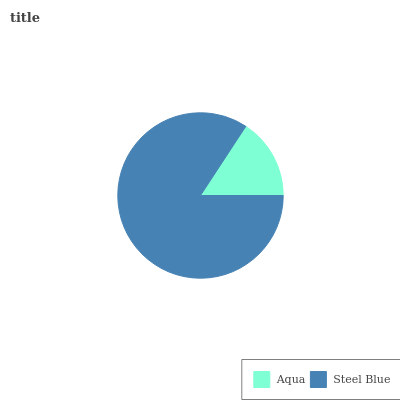Is Aqua the minimum?
Answer yes or no. Yes. Is Steel Blue the maximum?
Answer yes or no. Yes. Is Steel Blue the minimum?
Answer yes or no. No. Is Steel Blue greater than Aqua?
Answer yes or no. Yes. Is Aqua less than Steel Blue?
Answer yes or no. Yes. Is Aqua greater than Steel Blue?
Answer yes or no. No. Is Steel Blue less than Aqua?
Answer yes or no. No. Is Steel Blue the high median?
Answer yes or no. Yes. Is Aqua the low median?
Answer yes or no. Yes. Is Aqua the high median?
Answer yes or no. No. Is Steel Blue the low median?
Answer yes or no. No. 